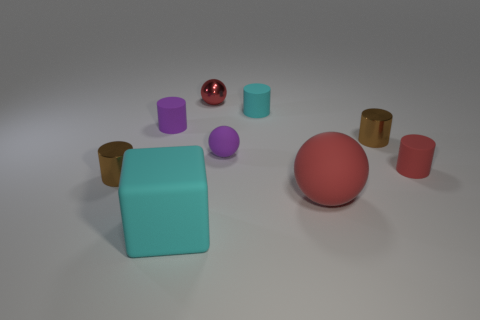How many objects are either small rubber objects on the left side of the big block or purple cylinders?
Offer a very short reply. 1. What number of other objects are the same size as the red rubber cylinder?
Your answer should be compact. 6. How big is the cyan object in front of the tiny cyan cylinder?
Provide a succinct answer. Large. The big red object that is the same material as the red cylinder is what shape?
Offer a very short reply. Sphere. Are there any other things of the same color as the small metallic sphere?
Ensure brevity in your answer.  Yes. There is a rubber sphere that is behind the tiny brown metallic cylinder on the left side of the large cyan thing; what is its color?
Offer a terse response. Purple. How many large things are gray rubber objects or rubber objects?
Provide a short and direct response. 2. What is the material of the cyan thing that is the same shape as the tiny red rubber thing?
Your response must be concise. Rubber. Are there any other things that are made of the same material as the big ball?
Offer a terse response. Yes. What is the color of the small shiny ball?
Give a very brief answer. Red. 